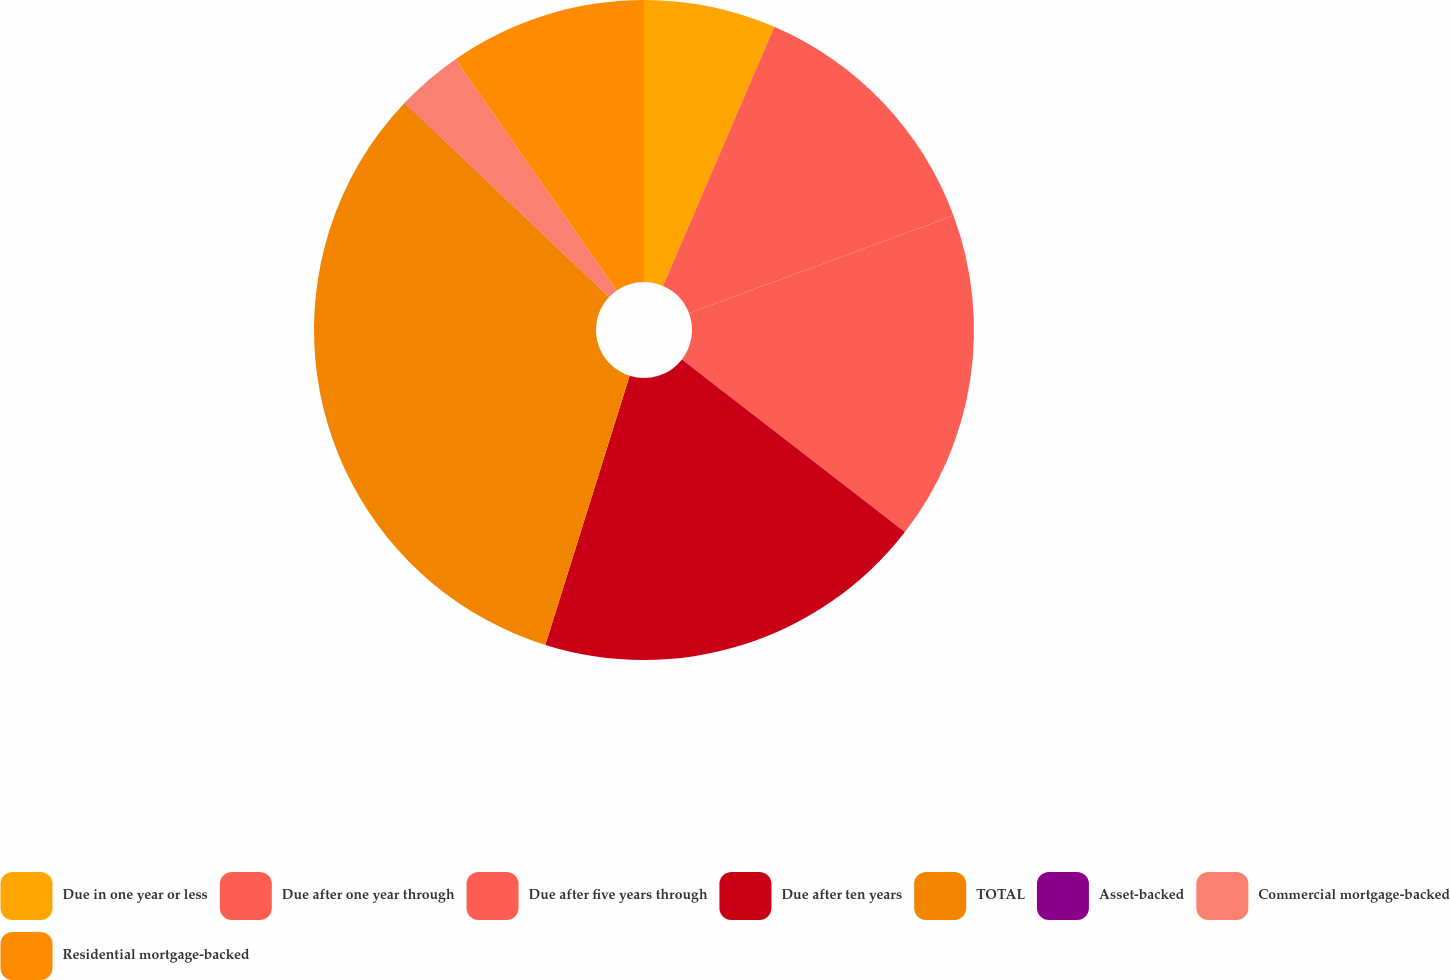Convert chart. <chart><loc_0><loc_0><loc_500><loc_500><pie_chart><fcel>Due in one year or less<fcel>Due after one year through<fcel>Due after five years through<fcel>Due after ten years<fcel>TOTAL<fcel>Asset-backed<fcel>Commercial mortgage-backed<fcel>Residential mortgage-backed<nl><fcel>6.46%<fcel>12.9%<fcel>16.13%<fcel>19.35%<fcel>32.24%<fcel>0.01%<fcel>3.24%<fcel>9.68%<nl></chart> 